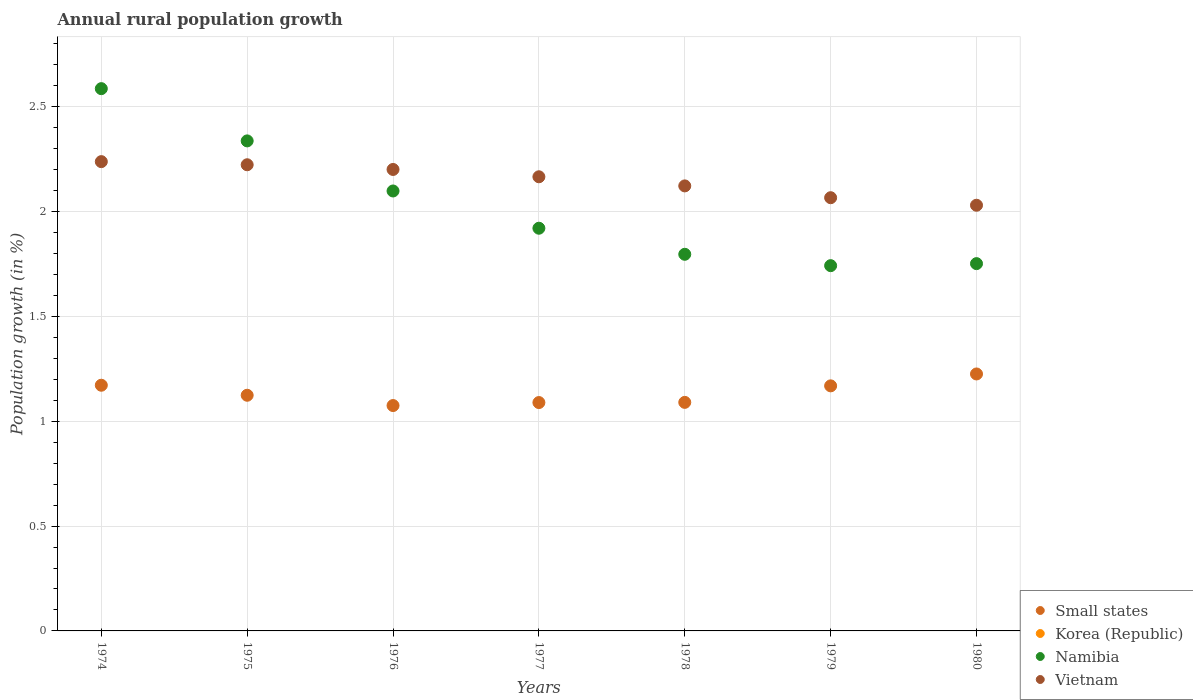What is the percentage of rural population growth in Vietnam in 1980?
Your response must be concise. 2.03. Across all years, what is the maximum percentage of rural population growth in Namibia?
Offer a terse response. 2.59. Across all years, what is the minimum percentage of rural population growth in Small states?
Offer a very short reply. 1.07. In which year was the percentage of rural population growth in Namibia maximum?
Your answer should be very brief. 1974. What is the total percentage of rural population growth in Korea (Republic) in the graph?
Give a very brief answer. 0. What is the difference between the percentage of rural population growth in Namibia in 1975 and that in 1979?
Ensure brevity in your answer.  0.6. What is the difference between the percentage of rural population growth in Small states in 1978 and the percentage of rural population growth in Vietnam in 1976?
Your answer should be very brief. -1.11. What is the average percentage of rural population growth in Small states per year?
Provide a succinct answer. 1.13. In the year 1978, what is the difference between the percentage of rural population growth in Small states and percentage of rural population growth in Namibia?
Your answer should be very brief. -0.71. In how many years, is the percentage of rural population growth in Namibia greater than 0.1 %?
Your response must be concise. 7. What is the ratio of the percentage of rural population growth in Small states in 1974 to that in 1976?
Ensure brevity in your answer.  1.09. Is the difference between the percentage of rural population growth in Small states in 1977 and 1978 greater than the difference between the percentage of rural population growth in Namibia in 1977 and 1978?
Make the answer very short. No. What is the difference between the highest and the second highest percentage of rural population growth in Vietnam?
Your answer should be compact. 0.01. What is the difference between the highest and the lowest percentage of rural population growth in Small states?
Keep it short and to the point. 0.15. In how many years, is the percentage of rural population growth in Korea (Republic) greater than the average percentage of rural population growth in Korea (Republic) taken over all years?
Offer a very short reply. 0. Is the sum of the percentage of rural population growth in Namibia in 1975 and 1976 greater than the maximum percentage of rural population growth in Small states across all years?
Offer a very short reply. Yes. Does the percentage of rural population growth in Korea (Republic) monotonically increase over the years?
Provide a short and direct response. No. Is the percentage of rural population growth in Namibia strictly greater than the percentage of rural population growth in Korea (Republic) over the years?
Your response must be concise. Yes. Is the percentage of rural population growth in Small states strictly less than the percentage of rural population growth in Namibia over the years?
Give a very brief answer. Yes. How many dotlines are there?
Offer a terse response. 3. What is the difference between two consecutive major ticks on the Y-axis?
Give a very brief answer. 0.5. How many legend labels are there?
Offer a very short reply. 4. How are the legend labels stacked?
Offer a very short reply. Vertical. What is the title of the graph?
Give a very brief answer. Annual rural population growth. What is the label or title of the Y-axis?
Provide a succinct answer. Population growth (in %). What is the Population growth (in %) of Small states in 1974?
Offer a terse response. 1.17. What is the Population growth (in %) in Korea (Republic) in 1974?
Your answer should be compact. 0. What is the Population growth (in %) in Namibia in 1974?
Provide a short and direct response. 2.59. What is the Population growth (in %) of Vietnam in 1974?
Your answer should be compact. 2.24. What is the Population growth (in %) of Small states in 1975?
Provide a succinct answer. 1.12. What is the Population growth (in %) in Namibia in 1975?
Provide a short and direct response. 2.34. What is the Population growth (in %) in Vietnam in 1975?
Your response must be concise. 2.22. What is the Population growth (in %) in Small states in 1976?
Offer a terse response. 1.07. What is the Population growth (in %) of Korea (Republic) in 1976?
Give a very brief answer. 0. What is the Population growth (in %) in Namibia in 1976?
Provide a short and direct response. 2.1. What is the Population growth (in %) in Vietnam in 1976?
Ensure brevity in your answer.  2.2. What is the Population growth (in %) in Small states in 1977?
Keep it short and to the point. 1.09. What is the Population growth (in %) in Namibia in 1977?
Offer a terse response. 1.92. What is the Population growth (in %) of Vietnam in 1977?
Make the answer very short. 2.17. What is the Population growth (in %) in Small states in 1978?
Ensure brevity in your answer.  1.09. What is the Population growth (in %) of Namibia in 1978?
Ensure brevity in your answer.  1.8. What is the Population growth (in %) in Vietnam in 1978?
Provide a short and direct response. 2.12. What is the Population growth (in %) of Small states in 1979?
Keep it short and to the point. 1.17. What is the Population growth (in %) of Namibia in 1979?
Provide a succinct answer. 1.74. What is the Population growth (in %) in Vietnam in 1979?
Provide a succinct answer. 2.07. What is the Population growth (in %) of Small states in 1980?
Your response must be concise. 1.23. What is the Population growth (in %) of Namibia in 1980?
Ensure brevity in your answer.  1.75. What is the Population growth (in %) in Vietnam in 1980?
Keep it short and to the point. 2.03. Across all years, what is the maximum Population growth (in %) in Small states?
Make the answer very short. 1.23. Across all years, what is the maximum Population growth (in %) of Namibia?
Provide a short and direct response. 2.59. Across all years, what is the maximum Population growth (in %) in Vietnam?
Make the answer very short. 2.24. Across all years, what is the minimum Population growth (in %) in Small states?
Provide a succinct answer. 1.07. Across all years, what is the minimum Population growth (in %) in Namibia?
Give a very brief answer. 1.74. Across all years, what is the minimum Population growth (in %) in Vietnam?
Offer a terse response. 2.03. What is the total Population growth (in %) in Small states in the graph?
Ensure brevity in your answer.  7.94. What is the total Population growth (in %) in Namibia in the graph?
Offer a very short reply. 14.23. What is the total Population growth (in %) in Vietnam in the graph?
Make the answer very short. 15.05. What is the difference between the Population growth (in %) of Small states in 1974 and that in 1975?
Keep it short and to the point. 0.05. What is the difference between the Population growth (in %) of Namibia in 1974 and that in 1975?
Provide a succinct answer. 0.25. What is the difference between the Population growth (in %) in Vietnam in 1974 and that in 1975?
Your answer should be very brief. 0.01. What is the difference between the Population growth (in %) of Small states in 1974 and that in 1976?
Offer a very short reply. 0.1. What is the difference between the Population growth (in %) of Namibia in 1974 and that in 1976?
Your answer should be compact. 0.49. What is the difference between the Population growth (in %) of Vietnam in 1974 and that in 1976?
Your response must be concise. 0.04. What is the difference between the Population growth (in %) of Small states in 1974 and that in 1977?
Your answer should be compact. 0.08. What is the difference between the Population growth (in %) in Namibia in 1974 and that in 1977?
Provide a short and direct response. 0.67. What is the difference between the Population growth (in %) of Vietnam in 1974 and that in 1977?
Make the answer very short. 0.07. What is the difference between the Population growth (in %) in Small states in 1974 and that in 1978?
Offer a very short reply. 0.08. What is the difference between the Population growth (in %) of Namibia in 1974 and that in 1978?
Your answer should be very brief. 0.79. What is the difference between the Population growth (in %) of Vietnam in 1974 and that in 1978?
Your response must be concise. 0.12. What is the difference between the Population growth (in %) in Small states in 1974 and that in 1979?
Your answer should be compact. 0. What is the difference between the Population growth (in %) in Namibia in 1974 and that in 1979?
Make the answer very short. 0.84. What is the difference between the Population growth (in %) of Vietnam in 1974 and that in 1979?
Make the answer very short. 0.17. What is the difference between the Population growth (in %) of Small states in 1974 and that in 1980?
Provide a short and direct response. -0.05. What is the difference between the Population growth (in %) in Namibia in 1974 and that in 1980?
Provide a succinct answer. 0.83. What is the difference between the Population growth (in %) of Vietnam in 1974 and that in 1980?
Make the answer very short. 0.21. What is the difference between the Population growth (in %) of Small states in 1975 and that in 1976?
Your response must be concise. 0.05. What is the difference between the Population growth (in %) of Namibia in 1975 and that in 1976?
Offer a terse response. 0.24. What is the difference between the Population growth (in %) of Vietnam in 1975 and that in 1976?
Give a very brief answer. 0.02. What is the difference between the Population growth (in %) in Small states in 1975 and that in 1977?
Provide a succinct answer. 0.03. What is the difference between the Population growth (in %) in Namibia in 1975 and that in 1977?
Provide a succinct answer. 0.42. What is the difference between the Population growth (in %) in Vietnam in 1975 and that in 1977?
Your answer should be very brief. 0.06. What is the difference between the Population growth (in %) in Small states in 1975 and that in 1978?
Ensure brevity in your answer.  0.03. What is the difference between the Population growth (in %) in Namibia in 1975 and that in 1978?
Ensure brevity in your answer.  0.54. What is the difference between the Population growth (in %) of Vietnam in 1975 and that in 1978?
Your answer should be compact. 0.1. What is the difference between the Population growth (in %) in Small states in 1975 and that in 1979?
Keep it short and to the point. -0.04. What is the difference between the Population growth (in %) of Namibia in 1975 and that in 1979?
Provide a short and direct response. 0.59. What is the difference between the Population growth (in %) of Vietnam in 1975 and that in 1979?
Ensure brevity in your answer.  0.16. What is the difference between the Population growth (in %) of Small states in 1975 and that in 1980?
Make the answer very short. -0.1. What is the difference between the Population growth (in %) in Namibia in 1975 and that in 1980?
Provide a short and direct response. 0.59. What is the difference between the Population growth (in %) of Vietnam in 1975 and that in 1980?
Make the answer very short. 0.19. What is the difference between the Population growth (in %) of Small states in 1976 and that in 1977?
Your response must be concise. -0.01. What is the difference between the Population growth (in %) of Namibia in 1976 and that in 1977?
Provide a short and direct response. 0.18. What is the difference between the Population growth (in %) of Vietnam in 1976 and that in 1977?
Your answer should be very brief. 0.03. What is the difference between the Population growth (in %) in Small states in 1976 and that in 1978?
Your response must be concise. -0.02. What is the difference between the Population growth (in %) of Namibia in 1976 and that in 1978?
Make the answer very short. 0.3. What is the difference between the Population growth (in %) of Vietnam in 1976 and that in 1978?
Keep it short and to the point. 0.08. What is the difference between the Population growth (in %) of Small states in 1976 and that in 1979?
Give a very brief answer. -0.09. What is the difference between the Population growth (in %) in Namibia in 1976 and that in 1979?
Ensure brevity in your answer.  0.36. What is the difference between the Population growth (in %) in Vietnam in 1976 and that in 1979?
Offer a very short reply. 0.13. What is the difference between the Population growth (in %) of Small states in 1976 and that in 1980?
Give a very brief answer. -0.15. What is the difference between the Population growth (in %) of Namibia in 1976 and that in 1980?
Your response must be concise. 0.35. What is the difference between the Population growth (in %) in Vietnam in 1976 and that in 1980?
Your answer should be compact. 0.17. What is the difference between the Population growth (in %) in Small states in 1977 and that in 1978?
Your answer should be compact. -0. What is the difference between the Population growth (in %) in Namibia in 1977 and that in 1978?
Offer a terse response. 0.12. What is the difference between the Population growth (in %) in Vietnam in 1977 and that in 1978?
Keep it short and to the point. 0.04. What is the difference between the Population growth (in %) in Small states in 1977 and that in 1979?
Make the answer very short. -0.08. What is the difference between the Population growth (in %) of Namibia in 1977 and that in 1979?
Give a very brief answer. 0.18. What is the difference between the Population growth (in %) in Vietnam in 1977 and that in 1979?
Provide a short and direct response. 0.1. What is the difference between the Population growth (in %) in Small states in 1977 and that in 1980?
Ensure brevity in your answer.  -0.14. What is the difference between the Population growth (in %) of Namibia in 1977 and that in 1980?
Ensure brevity in your answer.  0.17. What is the difference between the Population growth (in %) in Vietnam in 1977 and that in 1980?
Offer a terse response. 0.14. What is the difference between the Population growth (in %) of Small states in 1978 and that in 1979?
Provide a succinct answer. -0.08. What is the difference between the Population growth (in %) of Namibia in 1978 and that in 1979?
Make the answer very short. 0.05. What is the difference between the Population growth (in %) in Vietnam in 1978 and that in 1979?
Make the answer very short. 0.06. What is the difference between the Population growth (in %) in Small states in 1978 and that in 1980?
Offer a terse response. -0.14. What is the difference between the Population growth (in %) of Namibia in 1978 and that in 1980?
Give a very brief answer. 0.04. What is the difference between the Population growth (in %) of Vietnam in 1978 and that in 1980?
Your answer should be very brief. 0.09. What is the difference between the Population growth (in %) in Small states in 1979 and that in 1980?
Give a very brief answer. -0.06. What is the difference between the Population growth (in %) of Namibia in 1979 and that in 1980?
Your response must be concise. -0.01. What is the difference between the Population growth (in %) in Vietnam in 1979 and that in 1980?
Offer a terse response. 0.04. What is the difference between the Population growth (in %) in Small states in 1974 and the Population growth (in %) in Namibia in 1975?
Provide a short and direct response. -1.17. What is the difference between the Population growth (in %) in Small states in 1974 and the Population growth (in %) in Vietnam in 1975?
Provide a short and direct response. -1.05. What is the difference between the Population growth (in %) in Namibia in 1974 and the Population growth (in %) in Vietnam in 1975?
Your response must be concise. 0.36. What is the difference between the Population growth (in %) of Small states in 1974 and the Population growth (in %) of Namibia in 1976?
Give a very brief answer. -0.93. What is the difference between the Population growth (in %) of Small states in 1974 and the Population growth (in %) of Vietnam in 1976?
Provide a succinct answer. -1.03. What is the difference between the Population growth (in %) of Namibia in 1974 and the Population growth (in %) of Vietnam in 1976?
Offer a very short reply. 0.39. What is the difference between the Population growth (in %) in Small states in 1974 and the Population growth (in %) in Namibia in 1977?
Your answer should be compact. -0.75. What is the difference between the Population growth (in %) of Small states in 1974 and the Population growth (in %) of Vietnam in 1977?
Your answer should be very brief. -0.99. What is the difference between the Population growth (in %) in Namibia in 1974 and the Population growth (in %) in Vietnam in 1977?
Give a very brief answer. 0.42. What is the difference between the Population growth (in %) in Small states in 1974 and the Population growth (in %) in Namibia in 1978?
Ensure brevity in your answer.  -0.62. What is the difference between the Population growth (in %) in Small states in 1974 and the Population growth (in %) in Vietnam in 1978?
Your response must be concise. -0.95. What is the difference between the Population growth (in %) of Namibia in 1974 and the Population growth (in %) of Vietnam in 1978?
Keep it short and to the point. 0.46. What is the difference between the Population growth (in %) of Small states in 1974 and the Population growth (in %) of Namibia in 1979?
Give a very brief answer. -0.57. What is the difference between the Population growth (in %) of Small states in 1974 and the Population growth (in %) of Vietnam in 1979?
Provide a short and direct response. -0.89. What is the difference between the Population growth (in %) in Namibia in 1974 and the Population growth (in %) in Vietnam in 1979?
Offer a very short reply. 0.52. What is the difference between the Population growth (in %) of Small states in 1974 and the Population growth (in %) of Namibia in 1980?
Provide a short and direct response. -0.58. What is the difference between the Population growth (in %) in Small states in 1974 and the Population growth (in %) in Vietnam in 1980?
Your answer should be compact. -0.86. What is the difference between the Population growth (in %) in Namibia in 1974 and the Population growth (in %) in Vietnam in 1980?
Ensure brevity in your answer.  0.56. What is the difference between the Population growth (in %) in Small states in 1975 and the Population growth (in %) in Namibia in 1976?
Your answer should be compact. -0.97. What is the difference between the Population growth (in %) in Small states in 1975 and the Population growth (in %) in Vietnam in 1976?
Give a very brief answer. -1.08. What is the difference between the Population growth (in %) in Namibia in 1975 and the Population growth (in %) in Vietnam in 1976?
Your answer should be very brief. 0.14. What is the difference between the Population growth (in %) in Small states in 1975 and the Population growth (in %) in Namibia in 1977?
Provide a short and direct response. -0.8. What is the difference between the Population growth (in %) in Small states in 1975 and the Population growth (in %) in Vietnam in 1977?
Your response must be concise. -1.04. What is the difference between the Population growth (in %) in Namibia in 1975 and the Population growth (in %) in Vietnam in 1977?
Provide a succinct answer. 0.17. What is the difference between the Population growth (in %) in Small states in 1975 and the Population growth (in %) in Namibia in 1978?
Keep it short and to the point. -0.67. What is the difference between the Population growth (in %) of Small states in 1975 and the Population growth (in %) of Vietnam in 1978?
Ensure brevity in your answer.  -1. What is the difference between the Population growth (in %) of Namibia in 1975 and the Population growth (in %) of Vietnam in 1978?
Make the answer very short. 0.21. What is the difference between the Population growth (in %) of Small states in 1975 and the Population growth (in %) of Namibia in 1979?
Provide a short and direct response. -0.62. What is the difference between the Population growth (in %) of Small states in 1975 and the Population growth (in %) of Vietnam in 1979?
Keep it short and to the point. -0.94. What is the difference between the Population growth (in %) in Namibia in 1975 and the Population growth (in %) in Vietnam in 1979?
Your answer should be compact. 0.27. What is the difference between the Population growth (in %) of Small states in 1975 and the Population growth (in %) of Namibia in 1980?
Your answer should be compact. -0.63. What is the difference between the Population growth (in %) in Small states in 1975 and the Population growth (in %) in Vietnam in 1980?
Ensure brevity in your answer.  -0.91. What is the difference between the Population growth (in %) in Namibia in 1975 and the Population growth (in %) in Vietnam in 1980?
Make the answer very short. 0.31. What is the difference between the Population growth (in %) in Small states in 1976 and the Population growth (in %) in Namibia in 1977?
Offer a very short reply. -0.85. What is the difference between the Population growth (in %) of Small states in 1976 and the Population growth (in %) of Vietnam in 1977?
Your answer should be very brief. -1.09. What is the difference between the Population growth (in %) in Namibia in 1976 and the Population growth (in %) in Vietnam in 1977?
Make the answer very short. -0.07. What is the difference between the Population growth (in %) in Small states in 1976 and the Population growth (in %) in Namibia in 1978?
Your answer should be compact. -0.72. What is the difference between the Population growth (in %) of Small states in 1976 and the Population growth (in %) of Vietnam in 1978?
Your response must be concise. -1.05. What is the difference between the Population growth (in %) of Namibia in 1976 and the Population growth (in %) of Vietnam in 1978?
Make the answer very short. -0.02. What is the difference between the Population growth (in %) of Small states in 1976 and the Population growth (in %) of Namibia in 1979?
Provide a succinct answer. -0.67. What is the difference between the Population growth (in %) of Small states in 1976 and the Population growth (in %) of Vietnam in 1979?
Keep it short and to the point. -0.99. What is the difference between the Population growth (in %) of Namibia in 1976 and the Population growth (in %) of Vietnam in 1979?
Give a very brief answer. 0.03. What is the difference between the Population growth (in %) in Small states in 1976 and the Population growth (in %) in Namibia in 1980?
Keep it short and to the point. -0.68. What is the difference between the Population growth (in %) in Small states in 1976 and the Population growth (in %) in Vietnam in 1980?
Offer a terse response. -0.96. What is the difference between the Population growth (in %) of Namibia in 1976 and the Population growth (in %) of Vietnam in 1980?
Ensure brevity in your answer.  0.07. What is the difference between the Population growth (in %) of Small states in 1977 and the Population growth (in %) of Namibia in 1978?
Provide a short and direct response. -0.71. What is the difference between the Population growth (in %) of Small states in 1977 and the Population growth (in %) of Vietnam in 1978?
Your answer should be very brief. -1.03. What is the difference between the Population growth (in %) of Namibia in 1977 and the Population growth (in %) of Vietnam in 1978?
Your response must be concise. -0.2. What is the difference between the Population growth (in %) in Small states in 1977 and the Population growth (in %) in Namibia in 1979?
Make the answer very short. -0.65. What is the difference between the Population growth (in %) of Small states in 1977 and the Population growth (in %) of Vietnam in 1979?
Ensure brevity in your answer.  -0.98. What is the difference between the Population growth (in %) of Namibia in 1977 and the Population growth (in %) of Vietnam in 1979?
Offer a very short reply. -0.15. What is the difference between the Population growth (in %) of Small states in 1977 and the Population growth (in %) of Namibia in 1980?
Offer a terse response. -0.66. What is the difference between the Population growth (in %) of Small states in 1977 and the Population growth (in %) of Vietnam in 1980?
Offer a very short reply. -0.94. What is the difference between the Population growth (in %) of Namibia in 1977 and the Population growth (in %) of Vietnam in 1980?
Offer a terse response. -0.11. What is the difference between the Population growth (in %) in Small states in 1978 and the Population growth (in %) in Namibia in 1979?
Provide a short and direct response. -0.65. What is the difference between the Population growth (in %) in Small states in 1978 and the Population growth (in %) in Vietnam in 1979?
Make the answer very short. -0.98. What is the difference between the Population growth (in %) in Namibia in 1978 and the Population growth (in %) in Vietnam in 1979?
Your answer should be compact. -0.27. What is the difference between the Population growth (in %) of Small states in 1978 and the Population growth (in %) of Namibia in 1980?
Your answer should be compact. -0.66. What is the difference between the Population growth (in %) in Small states in 1978 and the Population growth (in %) in Vietnam in 1980?
Your answer should be compact. -0.94. What is the difference between the Population growth (in %) in Namibia in 1978 and the Population growth (in %) in Vietnam in 1980?
Provide a succinct answer. -0.23. What is the difference between the Population growth (in %) in Small states in 1979 and the Population growth (in %) in Namibia in 1980?
Ensure brevity in your answer.  -0.58. What is the difference between the Population growth (in %) in Small states in 1979 and the Population growth (in %) in Vietnam in 1980?
Provide a succinct answer. -0.86. What is the difference between the Population growth (in %) in Namibia in 1979 and the Population growth (in %) in Vietnam in 1980?
Your answer should be compact. -0.29. What is the average Population growth (in %) in Small states per year?
Keep it short and to the point. 1.13. What is the average Population growth (in %) in Korea (Republic) per year?
Ensure brevity in your answer.  0. What is the average Population growth (in %) in Namibia per year?
Give a very brief answer. 2.03. What is the average Population growth (in %) in Vietnam per year?
Offer a terse response. 2.15. In the year 1974, what is the difference between the Population growth (in %) of Small states and Population growth (in %) of Namibia?
Give a very brief answer. -1.41. In the year 1974, what is the difference between the Population growth (in %) of Small states and Population growth (in %) of Vietnam?
Your answer should be very brief. -1.07. In the year 1974, what is the difference between the Population growth (in %) in Namibia and Population growth (in %) in Vietnam?
Make the answer very short. 0.35. In the year 1975, what is the difference between the Population growth (in %) in Small states and Population growth (in %) in Namibia?
Ensure brevity in your answer.  -1.21. In the year 1975, what is the difference between the Population growth (in %) in Small states and Population growth (in %) in Vietnam?
Ensure brevity in your answer.  -1.1. In the year 1975, what is the difference between the Population growth (in %) in Namibia and Population growth (in %) in Vietnam?
Keep it short and to the point. 0.11. In the year 1976, what is the difference between the Population growth (in %) in Small states and Population growth (in %) in Namibia?
Your answer should be very brief. -1.02. In the year 1976, what is the difference between the Population growth (in %) in Small states and Population growth (in %) in Vietnam?
Your answer should be very brief. -1.13. In the year 1976, what is the difference between the Population growth (in %) in Namibia and Population growth (in %) in Vietnam?
Your answer should be very brief. -0.1. In the year 1977, what is the difference between the Population growth (in %) in Small states and Population growth (in %) in Namibia?
Your response must be concise. -0.83. In the year 1977, what is the difference between the Population growth (in %) in Small states and Population growth (in %) in Vietnam?
Give a very brief answer. -1.08. In the year 1977, what is the difference between the Population growth (in %) in Namibia and Population growth (in %) in Vietnam?
Provide a short and direct response. -0.25. In the year 1978, what is the difference between the Population growth (in %) of Small states and Population growth (in %) of Namibia?
Your response must be concise. -0.71. In the year 1978, what is the difference between the Population growth (in %) of Small states and Population growth (in %) of Vietnam?
Your answer should be compact. -1.03. In the year 1978, what is the difference between the Population growth (in %) in Namibia and Population growth (in %) in Vietnam?
Give a very brief answer. -0.33. In the year 1979, what is the difference between the Population growth (in %) in Small states and Population growth (in %) in Namibia?
Provide a short and direct response. -0.57. In the year 1979, what is the difference between the Population growth (in %) in Small states and Population growth (in %) in Vietnam?
Provide a short and direct response. -0.9. In the year 1979, what is the difference between the Population growth (in %) in Namibia and Population growth (in %) in Vietnam?
Offer a terse response. -0.32. In the year 1980, what is the difference between the Population growth (in %) of Small states and Population growth (in %) of Namibia?
Your answer should be compact. -0.53. In the year 1980, what is the difference between the Population growth (in %) of Small states and Population growth (in %) of Vietnam?
Offer a very short reply. -0.8. In the year 1980, what is the difference between the Population growth (in %) of Namibia and Population growth (in %) of Vietnam?
Keep it short and to the point. -0.28. What is the ratio of the Population growth (in %) of Small states in 1974 to that in 1975?
Your answer should be very brief. 1.04. What is the ratio of the Population growth (in %) in Namibia in 1974 to that in 1975?
Your response must be concise. 1.11. What is the ratio of the Population growth (in %) of Vietnam in 1974 to that in 1975?
Ensure brevity in your answer.  1.01. What is the ratio of the Population growth (in %) of Small states in 1974 to that in 1976?
Make the answer very short. 1.09. What is the ratio of the Population growth (in %) in Namibia in 1974 to that in 1976?
Offer a very short reply. 1.23. What is the ratio of the Population growth (in %) of Vietnam in 1974 to that in 1976?
Offer a terse response. 1.02. What is the ratio of the Population growth (in %) in Small states in 1974 to that in 1977?
Offer a very short reply. 1.08. What is the ratio of the Population growth (in %) in Namibia in 1974 to that in 1977?
Ensure brevity in your answer.  1.35. What is the ratio of the Population growth (in %) of Small states in 1974 to that in 1978?
Provide a succinct answer. 1.07. What is the ratio of the Population growth (in %) of Namibia in 1974 to that in 1978?
Provide a succinct answer. 1.44. What is the ratio of the Population growth (in %) of Vietnam in 1974 to that in 1978?
Offer a very short reply. 1.05. What is the ratio of the Population growth (in %) of Small states in 1974 to that in 1979?
Ensure brevity in your answer.  1. What is the ratio of the Population growth (in %) of Namibia in 1974 to that in 1979?
Provide a succinct answer. 1.48. What is the ratio of the Population growth (in %) of Small states in 1974 to that in 1980?
Offer a very short reply. 0.96. What is the ratio of the Population growth (in %) in Namibia in 1974 to that in 1980?
Offer a terse response. 1.48. What is the ratio of the Population growth (in %) in Vietnam in 1974 to that in 1980?
Ensure brevity in your answer.  1.1. What is the ratio of the Population growth (in %) of Small states in 1975 to that in 1976?
Offer a terse response. 1.05. What is the ratio of the Population growth (in %) of Namibia in 1975 to that in 1976?
Your response must be concise. 1.11. What is the ratio of the Population growth (in %) of Vietnam in 1975 to that in 1976?
Make the answer very short. 1.01. What is the ratio of the Population growth (in %) in Small states in 1975 to that in 1977?
Keep it short and to the point. 1.03. What is the ratio of the Population growth (in %) in Namibia in 1975 to that in 1977?
Offer a very short reply. 1.22. What is the ratio of the Population growth (in %) of Vietnam in 1975 to that in 1977?
Your response must be concise. 1.03. What is the ratio of the Population growth (in %) in Small states in 1975 to that in 1978?
Offer a terse response. 1.03. What is the ratio of the Population growth (in %) in Namibia in 1975 to that in 1978?
Make the answer very short. 1.3. What is the ratio of the Population growth (in %) in Vietnam in 1975 to that in 1978?
Your response must be concise. 1.05. What is the ratio of the Population growth (in %) of Small states in 1975 to that in 1979?
Give a very brief answer. 0.96. What is the ratio of the Population growth (in %) of Namibia in 1975 to that in 1979?
Offer a very short reply. 1.34. What is the ratio of the Population growth (in %) of Vietnam in 1975 to that in 1979?
Keep it short and to the point. 1.08. What is the ratio of the Population growth (in %) in Small states in 1975 to that in 1980?
Give a very brief answer. 0.92. What is the ratio of the Population growth (in %) of Namibia in 1975 to that in 1980?
Make the answer very short. 1.33. What is the ratio of the Population growth (in %) of Vietnam in 1975 to that in 1980?
Make the answer very short. 1.1. What is the ratio of the Population growth (in %) in Small states in 1976 to that in 1977?
Your answer should be compact. 0.99. What is the ratio of the Population growth (in %) of Namibia in 1976 to that in 1977?
Provide a short and direct response. 1.09. What is the ratio of the Population growth (in %) in Vietnam in 1976 to that in 1977?
Your answer should be very brief. 1.02. What is the ratio of the Population growth (in %) in Small states in 1976 to that in 1978?
Your response must be concise. 0.99. What is the ratio of the Population growth (in %) of Namibia in 1976 to that in 1978?
Your answer should be compact. 1.17. What is the ratio of the Population growth (in %) of Vietnam in 1976 to that in 1978?
Offer a terse response. 1.04. What is the ratio of the Population growth (in %) in Small states in 1976 to that in 1979?
Give a very brief answer. 0.92. What is the ratio of the Population growth (in %) of Namibia in 1976 to that in 1979?
Provide a succinct answer. 1.2. What is the ratio of the Population growth (in %) in Vietnam in 1976 to that in 1979?
Provide a succinct answer. 1.07. What is the ratio of the Population growth (in %) of Small states in 1976 to that in 1980?
Your response must be concise. 0.88. What is the ratio of the Population growth (in %) of Namibia in 1976 to that in 1980?
Make the answer very short. 1.2. What is the ratio of the Population growth (in %) of Vietnam in 1976 to that in 1980?
Offer a terse response. 1.08. What is the ratio of the Population growth (in %) in Small states in 1977 to that in 1978?
Ensure brevity in your answer.  1. What is the ratio of the Population growth (in %) of Namibia in 1977 to that in 1978?
Ensure brevity in your answer.  1.07. What is the ratio of the Population growth (in %) of Vietnam in 1977 to that in 1978?
Make the answer very short. 1.02. What is the ratio of the Population growth (in %) in Small states in 1977 to that in 1979?
Your answer should be very brief. 0.93. What is the ratio of the Population growth (in %) in Namibia in 1977 to that in 1979?
Offer a very short reply. 1.1. What is the ratio of the Population growth (in %) of Vietnam in 1977 to that in 1979?
Your answer should be compact. 1.05. What is the ratio of the Population growth (in %) in Small states in 1977 to that in 1980?
Give a very brief answer. 0.89. What is the ratio of the Population growth (in %) in Namibia in 1977 to that in 1980?
Give a very brief answer. 1.1. What is the ratio of the Population growth (in %) of Vietnam in 1977 to that in 1980?
Keep it short and to the point. 1.07. What is the ratio of the Population growth (in %) in Small states in 1978 to that in 1979?
Provide a short and direct response. 0.93. What is the ratio of the Population growth (in %) in Namibia in 1978 to that in 1979?
Offer a terse response. 1.03. What is the ratio of the Population growth (in %) in Vietnam in 1978 to that in 1979?
Your answer should be compact. 1.03. What is the ratio of the Population growth (in %) in Small states in 1978 to that in 1980?
Offer a terse response. 0.89. What is the ratio of the Population growth (in %) of Namibia in 1978 to that in 1980?
Provide a succinct answer. 1.03. What is the ratio of the Population growth (in %) in Vietnam in 1978 to that in 1980?
Ensure brevity in your answer.  1.05. What is the ratio of the Population growth (in %) of Small states in 1979 to that in 1980?
Provide a succinct answer. 0.95. What is the ratio of the Population growth (in %) in Namibia in 1979 to that in 1980?
Give a very brief answer. 0.99. What is the ratio of the Population growth (in %) in Vietnam in 1979 to that in 1980?
Offer a terse response. 1.02. What is the difference between the highest and the second highest Population growth (in %) of Small states?
Make the answer very short. 0.05. What is the difference between the highest and the second highest Population growth (in %) in Namibia?
Your response must be concise. 0.25. What is the difference between the highest and the second highest Population growth (in %) in Vietnam?
Offer a terse response. 0.01. What is the difference between the highest and the lowest Population growth (in %) of Small states?
Offer a very short reply. 0.15. What is the difference between the highest and the lowest Population growth (in %) in Namibia?
Give a very brief answer. 0.84. What is the difference between the highest and the lowest Population growth (in %) in Vietnam?
Give a very brief answer. 0.21. 